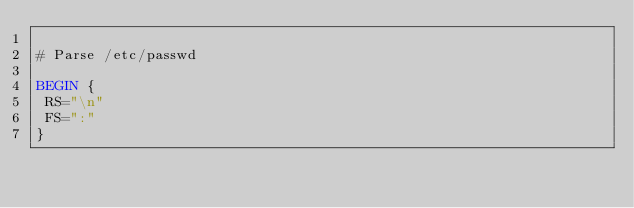<code> <loc_0><loc_0><loc_500><loc_500><_Awk_>
# Parse /etc/passwd

BEGIN {
 RS="\n"
 FS=":"
}
</code> 